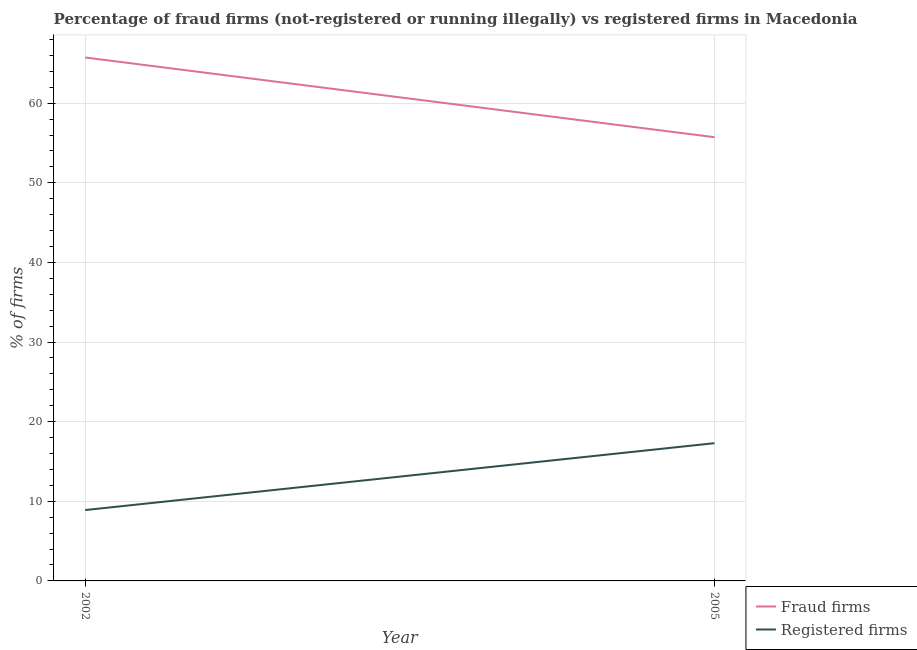Does the line corresponding to percentage of registered firms intersect with the line corresponding to percentage of fraud firms?
Offer a terse response. No. What is the percentage of fraud firms in 2002?
Your response must be concise. 65.74. Across all years, what is the maximum percentage of registered firms?
Provide a short and direct response. 17.3. Across all years, what is the minimum percentage of fraud firms?
Your answer should be compact. 55.73. In which year was the percentage of registered firms maximum?
Your response must be concise. 2005. In which year was the percentage of registered firms minimum?
Your answer should be compact. 2002. What is the total percentage of registered firms in the graph?
Make the answer very short. 26.2. What is the difference between the percentage of fraud firms in 2002 and that in 2005?
Your answer should be very brief. 10.01. What is the difference between the percentage of fraud firms in 2005 and the percentage of registered firms in 2002?
Your response must be concise. 46.83. What is the average percentage of registered firms per year?
Offer a terse response. 13.1. In the year 2002, what is the difference between the percentage of fraud firms and percentage of registered firms?
Provide a short and direct response. 56.84. In how many years, is the percentage of registered firms greater than 58 %?
Provide a short and direct response. 0. What is the ratio of the percentage of fraud firms in 2002 to that in 2005?
Offer a terse response. 1.18. Is the percentage of registered firms in 2002 less than that in 2005?
Your answer should be compact. Yes. In how many years, is the percentage of registered firms greater than the average percentage of registered firms taken over all years?
Your answer should be compact. 1. Is the percentage of registered firms strictly less than the percentage of fraud firms over the years?
Your response must be concise. Yes. How many lines are there?
Keep it short and to the point. 2. What is the difference between two consecutive major ticks on the Y-axis?
Your answer should be compact. 10. Does the graph contain any zero values?
Offer a terse response. No. How many legend labels are there?
Make the answer very short. 2. How are the legend labels stacked?
Provide a short and direct response. Vertical. What is the title of the graph?
Provide a succinct answer. Percentage of fraud firms (not-registered or running illegally) vs registered firms in Macedonia. Does "Female labor force" appear as one of the legend labels in the graph?
Your answer should be very brief. No. What is the label or title of the Y-axis?
Your answer should be very brief. % of firms. What is the % of firms of Fraud firms in 2002?
Your answer should be compact. 65.74. What is the % of firms of Fraud firms in 2005?
Offer a very short reply. 55.73. What is the % of firms in Registered firms in 2005?
Your answer should be very brief. 17.3. Across all years, what is the maximum % of firms of Fraud firms?
Your answer should be compact. 65.74. Across all years, what is the minimum % of firms of Fraud firms?
Ensure brevity in your answer.  55.73. What is the total % of firms in Fraud firms in the graph?
Provide a succinct answer. 121.47. What is the total % of firms of Registered firms in the graph?
Offer a very short reply. 26.2. What is the difference between the % of firms of Fraud firms in 2002 and that in 2005?
Offer a terse response. 10.01. What is the difference between the % of firms of Fraud firms in 2002 and the % of firms of Registered firms in 2005?
Give a very brief answer. 48.44. What is the average % of firms in Fraud firms per year?
Provide a short and direct response. 60.73. What is the average % of firms in Registered firms per year?
Make the answer very short. 13.1. In the year 2002, what is the difference between the % of firms in Fraud firms and % of firms in Registered firms?
Ensure brevity in your answer.  56.84. In the year 2005, what is the difference between the % of firms of Fraud firms and % of firms of Registered firms?
Offer a very short reply. 38.43. What is the ratio of the % of firms in Fraud firms in 2002 to that in 2005?
Your response must be concise. 1.18. What is the ratio of the % of firms of Registered firms in 2002 to that in 2005?
Keep it short and to the point. 0.51. What is the difference between the highest and the second highest % of firms of Fraud firms?
Offer a terse response. 10.01. What is the difference between the highest and the second highest % of firms in Registered firms?
Your answer should be very brief. 8.4. What is the difference between the highest and the lowest % of firms of Fraud firms?
Ensure brevity in your answer.  10.01. What is the difference between the highest and the lowest % of firms in Registered firms?
Your answer should be very brief. 8.4. 